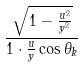<formula> <loc_0><loc_0><loc_500><loc_500>\frac { \sqrt { 1 - \frac { u ^ { 2 } } { y ^ { 2 } } } } { 1 \cdot \frac { u } { y } \cos \theta _ { k } }</formula> 